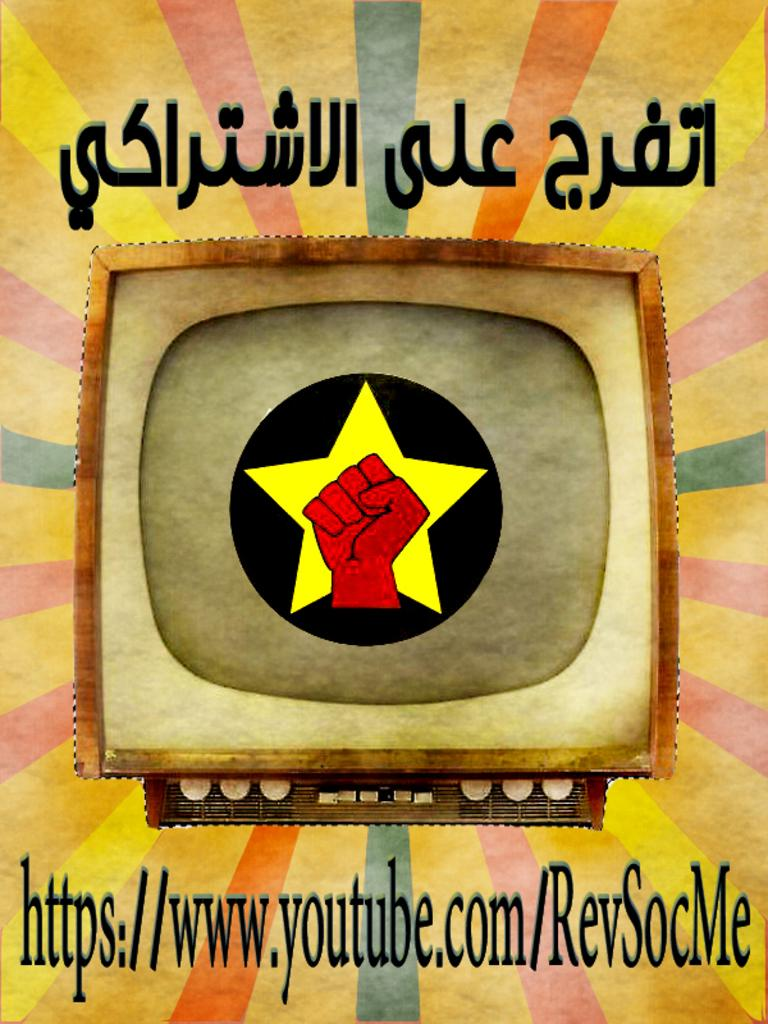<image>
Give a short and clear explanation of the subsequent image. an artistic image for revsoc me youtube channel. 